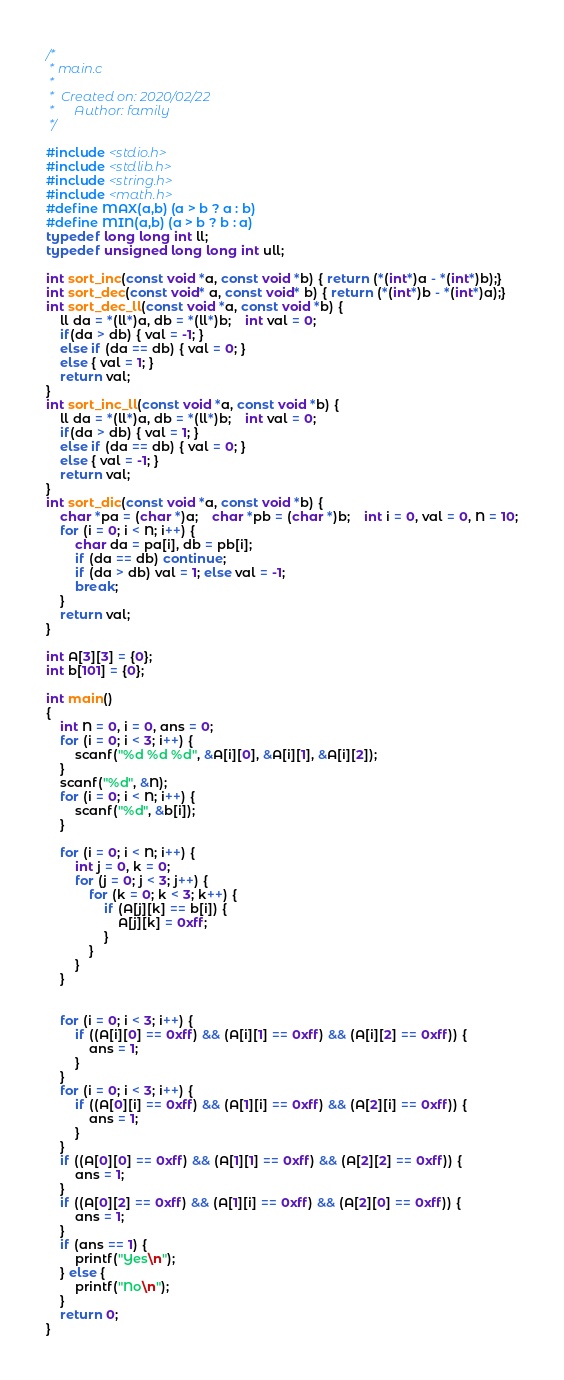Convert code to text. <code><loc_0><loc_0><loc_500><loc_500><_C_>/*
 * main.c
 *
 *  Created on: 2020/02/22
 *      Author: family
 */

#include <stdio.h>
#include <stdlib.h>
#include <string.h>
#include <math.h>
#define MAX(a,b) (a > b ? a : b)
#define MIN(a,b) (a > b ? b : a)
typedef long long int ll;
typedef unsigned long long int ull;

int sort_inc(const void *a, const void *b) { return (*(int*)a - *(int*)b);}
int sort_dec(const void* a, const void* b) { return (*(int*)b - *(int*)a);}
int sort_dec_ll(const void *a, const void *b) {
    ll da = *(ll*)a, db = *(ll*)b;    int val = 0;
    if(da > db) { val = -1; }
    else if (da == db) { val = 0; }
    else { val = 1; }
    return val;
}
int sort_inc_ll(const void *a, const void *b) {
    ll da = *(ll*)a, db = *(ll*)b;    int val = 0;
    if(da > db) { val = 1; }
    else if (da == db) { val = 0; }
    else { val = -1; }
    return val;
}
int sort_dic(const void *a, const void *b) {
    char *pa = (char *)a;    char *pb = (char *)b;    int i = 0, val = 0, N = 10;
    for (i = 0; i < N; i++) {
    	char da = pa[i], db = pb[i];
    	if (da == db) continue;
  		if (da > db) val = 1; else val = -1;
        break;
    }
    return val;
}

int A[3][3] = {0};
int b[101] = {0};

int main()
{
	int N = 0, i = 0, ans = 0;
	for (i = 0; i < 3; i++) {
		scanf("%d %d %d", &A[i][0], &A[i][1], &A[i][2]);
	}
	scanf("%d", &N);
	for (i = 0; i < N; i++) {
		scanf("%d", &b[i]);
	}

	for (i = 0; i < N; i++) {
		int j = 0, k = 0;
		for (j = 0; j < 3; j++) {
			for (k = 0; k < 3; k++) {
				if (A[j][k] == b[i]) {
					A[j][k] = 0xff;
				}
			}
		}
	}


	for (i = 0; i < 3; i++) {
		if ((A[i][0] == 0xff) && (A[i][1] == 0xff) && (A[i][2] == 0xff)) {
			ans = 1;
		}
	}
	for (i = 0; i < 3; i++) {
		if ((A[0][i] == 0xff) && (A[1][i] == 0xff) && (A[2][i] == 0xff)) {
			ans = 1;
		}
	}
	if ((A[0][0] == 0xff) && (A[1][1] == 0xff) && (A[2][2] == 0xff)) {
		ans = 1;
	}
	if ((A[0][2] == 0xff) && (A[1][i] == 0xff) && (A[2][0] == 0xff)) {
		ans = 1;
	}
	if (ans == 1) {
		printf("Yes\n");
	} else {
		printf("No\n");
	}
    return 0;
}
</code> 